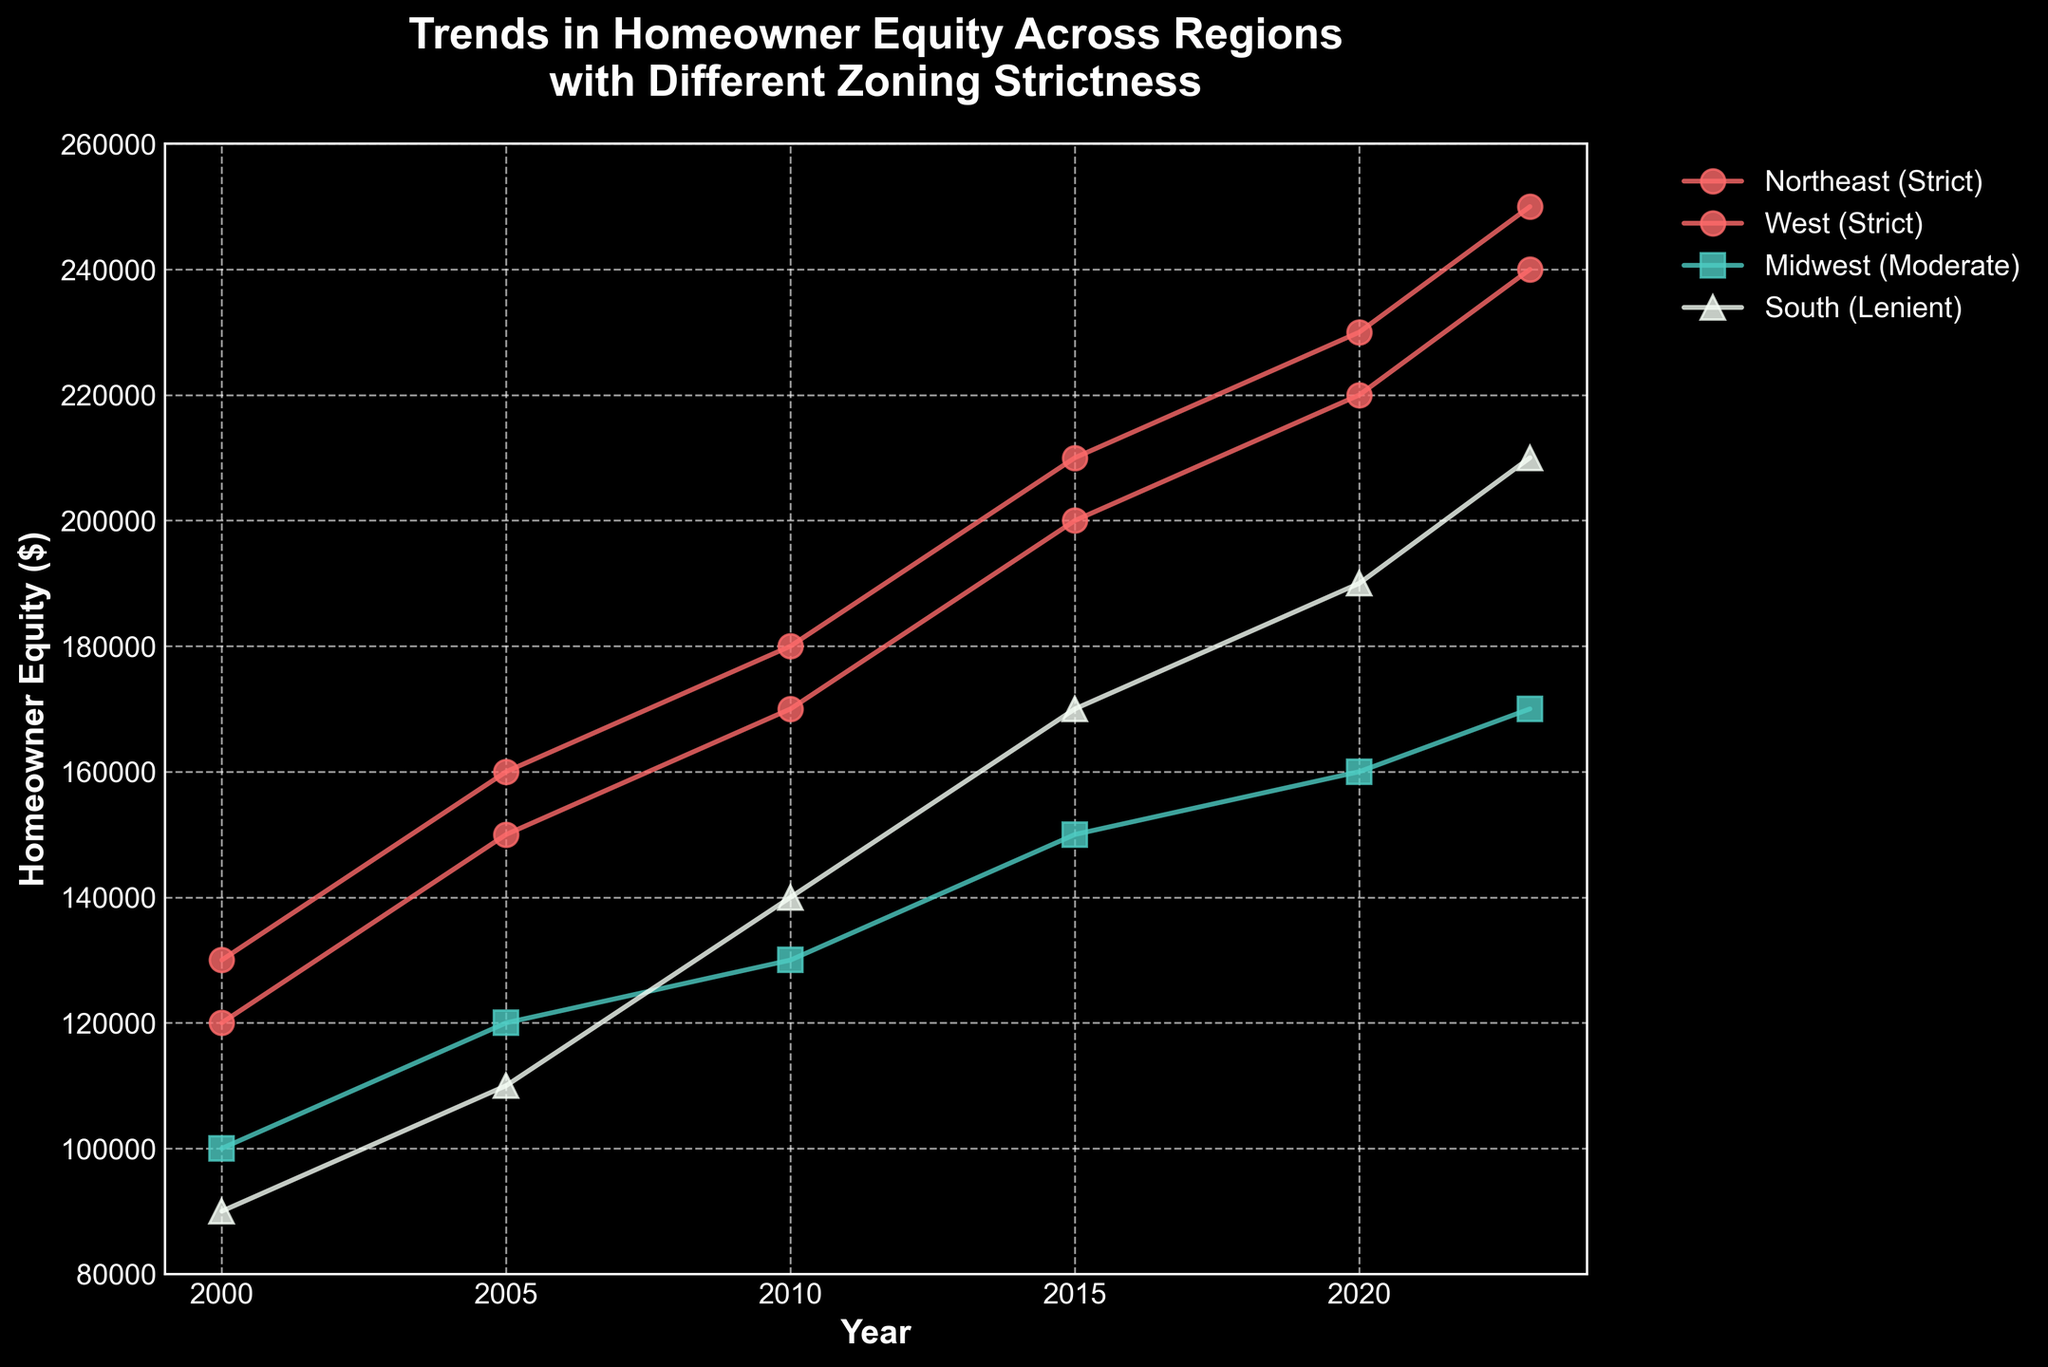What is the title of the plot? The title is displayed at the top of the chart in bold font. It reads: "Trends in Homeowner Equity Across Regions with Different Zoning Strictness".
Answer: Trends in Homeowner Equity Across Regions with Different Zoning Strictness What years are included in the x-axis of the plot? The x-axis labels range from 2000 to 2023, representing the years for which the data is plotted.
Answer: 2000 to 2023 Which region had the highest homeowner equity in 2023? In 2023, the West region with strict zoning had the highest homeowner equity, as indicated by the highest point on the plot for that year.
Answer: West How does homeowner equity in the Midwest region change from 2000 to 2023? By comparing the data points for Midwest from 2000 to 2023, we see that equity increased from $100,000 to $170,000 over these years.
Answer: Increased from $100,000 to $170,000 What color represents regions with lenient zoning? The colors differentiate zoning strictness, with lenient zoning represented by a bright green color.
Answer: Bright green Which region saw the largest increase in homeowner equity from 2000 to 2023? By reviewing the entire time series for each region, the West region, with strict zoning, increased from $130,000 in 2000 to $250,000 in 2023, showing the largest increase of $120,000.
Answer: West What is the overall trend for regions with moderate zoning from 2000 to 2023? Reviewing the data points for regions with moderate zoning, homeowner equity consistently increased from $100,000 in 2000 to $170,000 in 2023.
Answer: Increasing Compare the homeowner equity of the Northeast and the South in 2010. In 2010, the equity in the Northeast (strict zoning) was $170,000, whereas in the South (lenient zoning), it was $140,000.
Answer: Northeast had higher equity Between 2015 and 2020, which region had the smallest increase in homeowner equity? By comparing the data points between 2015 and 2020 for all regions, the Midwest (moderate zoning) saw the smallest increase from $150,000 to $160,000, an increase of $10,000.
Answer: Midwest What is the slope of the trendline for the South region from 2000 to 2023? Calculating the change in equity ($210,000 - $90,000) over the time period (2023 - 2000) gives a slope of approximately $5,217 per year.
Answer: $5,217 per year 